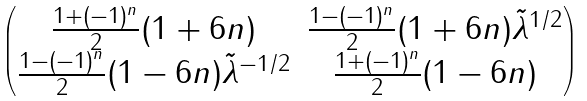Convert formula to latex. <formula><loc_0><loc_0><loc_500><loc_500>\begin{pmatrix} \frac { 1 + ( - 1 ) ^ { n } } { 2 } ( 1 + 6 n ) & \frac { 1 - ( - 1 ) ^ { n } } { 2 } ( 1 + 6 n ) \tilde { \lambda } ^ { 1 / 2 } \\ \frac { 1 - ( - 1 ) ^ { n } } { 2 } ( 1 - 6 n ) \tilde { \lambda } ^ { - 1 / 2 } & \frac { 1 + ( - 1 ) ^ { n } } { 2 } ( 1 - 6 n ) \end{pmatrix}</formula> 